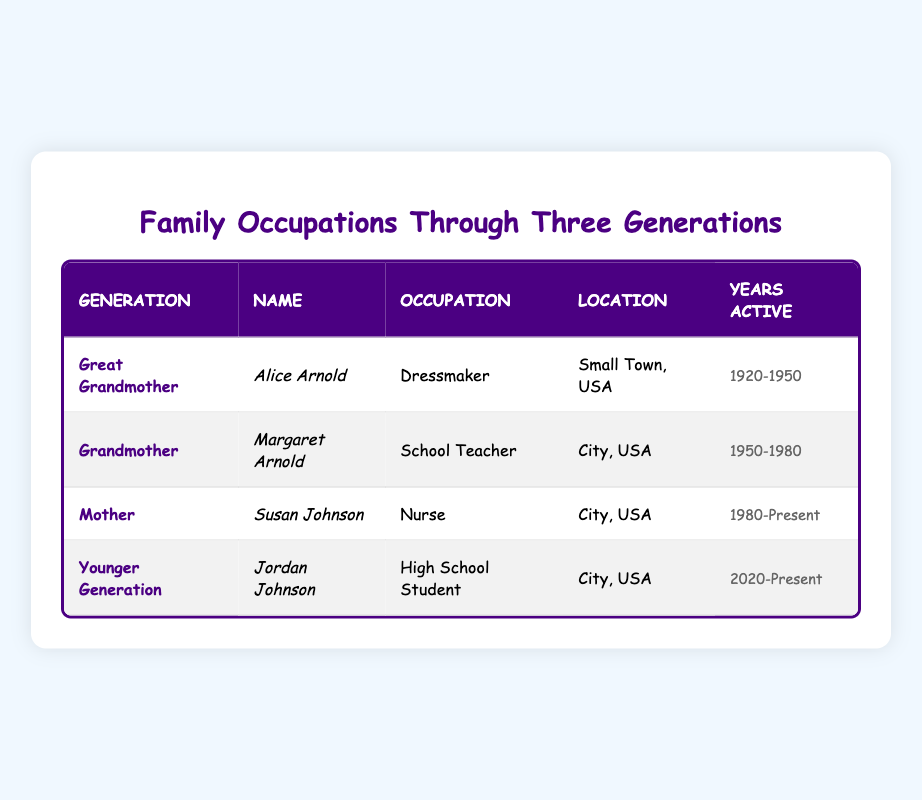What was the occupation of Alice Arnold? Alice Arnold is listed under the "Great Grandmother" generation, and her occupation in the table is "Dressmaker."
Answer: Dressmaker In which city did Margaret Arnold work as a teacher? The table indicates that Margaret Arnold, the "Grandmother," worked as a school teacher in "City, USA."
Answer: City, USA How many years was Susan Johnson active in her occupation? To find out how many years Susan Johnson was active, we look at her years active: "1980-Present." Calculating from 1980 to the present date (assumed to be 2023), she has been active for approximately 43 years.
Answer: 43 years Is Jordan Johnson currently working? Jordan Johnson is listed as a "High School Student" and is marked as being active from "2020-Present," indicating that he is still in school, not working.
Answer: No Which generation had an occupation in the medical field? Looking through the table, we see that Susan Johnson, who belongs to the "Mother" generation, is a "Nurse," which is in the medical field.
Answer: Mother What is the difference in years active between Margaret Arnold and Alice Arnold? Alice Arnold was active from 1920 to 1950, totaling 30 years (1950 - 1920). Margaret Arnold was active from 1950 to 1980, totaling 30 years as well (1980 - 1950). Therefore, the difference is 0 years since both were active for the same duration.
Answer: 0 years How many members of the family were active in occupations before the year 2000? In the table, Alice Arnold (1920-1950), Margaret Arnold (1950-1980), and Susan Johnson (1980-Present) were all active before 2000. Jordan Johnson was not active before 2000. Thus, there are three members active before that year.
Answer: 3 members Which occupation was taken up by both grandmothers? According to the table, Alice Arnold was a "Dressmaker" and Margaret Arnold was a "School Teacher." Since these are different occupations, there was no overlap in the occupations taken by both grandmothers.
Answer: No overlapping occupation What is the trend of occupations from generation to generation? Based on the table, earlier generations had occupations focused more on craft and education (dressmaker and teacher), while recent generations are involved in more modern roles, like nursing and studying. This trend indicates a shift towards professional and educational backgrounds.
Answer: Shift towards professional roles 